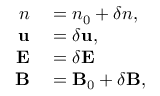Convert formula to latex. <formula><loc_0><loc_0><loc_500><loc_500>\begin{array} { r l } { n } & = n _ { 0 } + \delta n , } \\ { u } & = \delta u , } \\ { E } & = \delta E } \\ { B } & = B _ { 0 } + \delta B , } \end{array}</formula> 